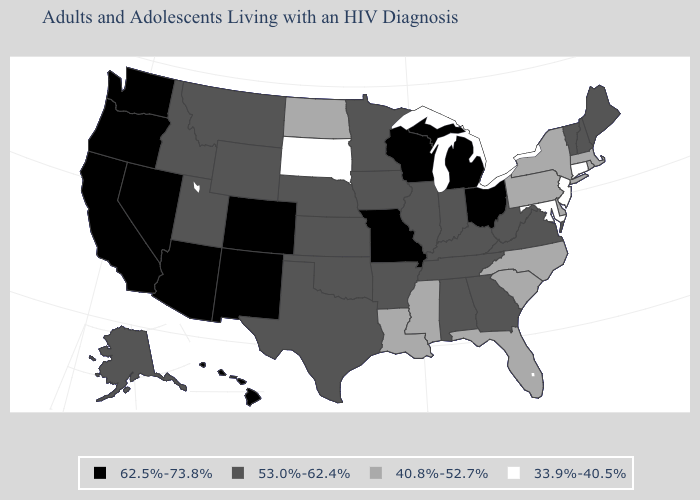Among the states that border Vermont , which have the lowest value?
Give a very brief answer. Massachusetts, New York. Name the states that have a value in the range 40.8%-52.7%?
Short answer required. Delaware, Florida, Louisiana, Massachusetts, Mississippi, New York, North Carolina, North Dakota, Pennsylvania, Rhode Island, South Carolina. How many symbols are there in the legend?
Concise answer only. 4. Which states have the highest value in the USA?
Write a very short answer. Arizona, California, Colorado, Hawaii, Michigan, Missouri, Nevada, New Mexico, Ohio, Oregon, Washington, Wisconsin. What is the value of West Virginia?
Keep it brief. 53.0%-62.4%. What is the value of Hawaii?
Be succinct. 62.5%-73.8%. Which states have the lowest value in the USA?
Quick response, please. Connecticut, Maryland, New Jersey, South Dakota. What is the value of New Hampshire?
Be succinct. 53.0%-62.4%. Name the states that have a value in the range 33.9%-40.5%?
Short answer required. Connecticut, Maryland, New Jersey, South Dakota. Name the states that have a value in the range 33.9%-40.5%?
Be succinct. Connecticut, Maryland, New Jersey, South Dakota. Name the states that have a value in the range 53.0%-62.4%?
Short answer required. Alabama, Alaska, Arkansas, Georgia, Idaho, Illinois, Indiana, Iowa, Kansas, Kentucky, Maine, Minnesota, Montana, Nebraska, New Hampshire, Oklahoma, Tennessee, Texas, Utah, Vermont, Virginia, West Virginia, Wyoming. Which states hav the highest value in the South?
Be succinct. Alabama, Arkansas, Georgia, Kentucky, Oklahoma, Tennessee, Texas, Virginia, West Virginia. Name the states that have a value in the range 40.8%-52.7%?
Write a very short answer. Delaware, Florida, Louisiana, Massachusetts, Mississippi, New York, North Carolina, North Dakota, Pennsylvania, Rhode Island, South Carolina. How many symbols are there in the legend?
Concise answer only. 4. 